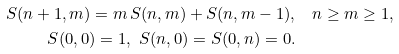<formula> <loc_0><loc_0><loc_500><loc_500>S ( n + 1 , m ) = m \, S ( n , m ) + S ( n , m - 1 ) , & \quad n \geq m \geq 1 , \\ S ( 0 , 0 ) = 1 , \ S ( n , 0 ) = S ( 0 , n ) = 0 . &</formula> 